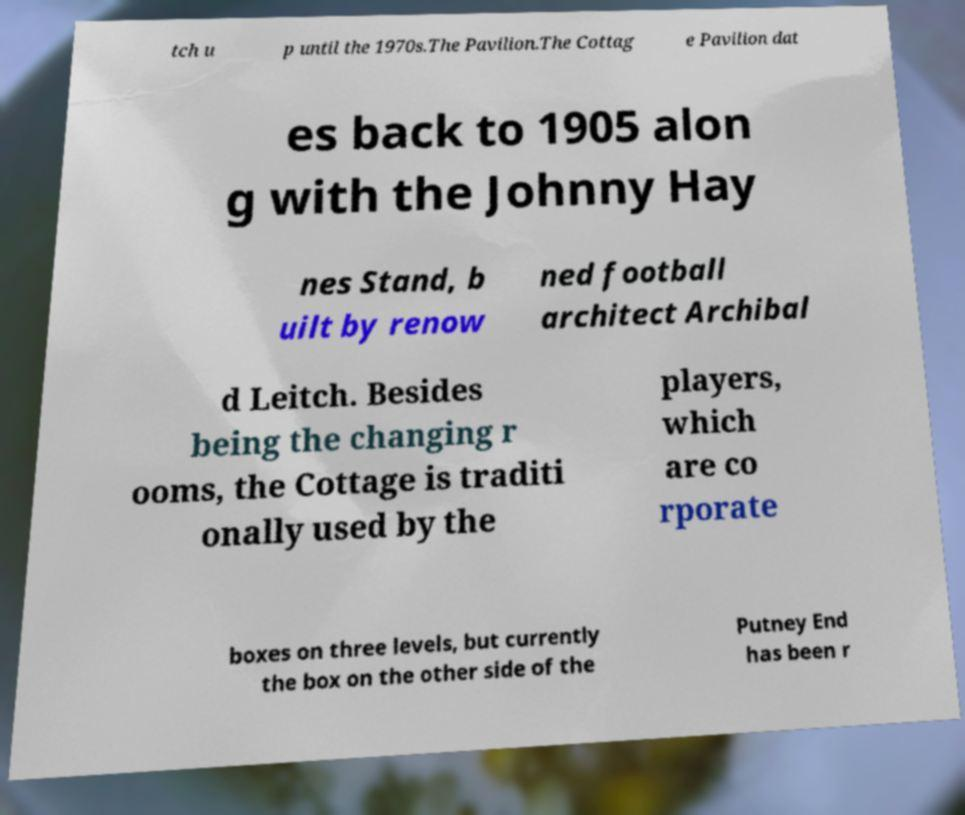Please identify and transcribe the text found in this image. tch u p until the 1970s.The Pavilion.The Cottag e Pavilion dat es back to 1905 alon g with the Johnny Hay nes Stand, b uilt by renow ned football architect Archibal d Leitch. Besides being the changing r ooms, the Cottage is traditi onally used by the players, which are co rporate boxes on three levels, but currently the box on the other side of the Putney End has been r 